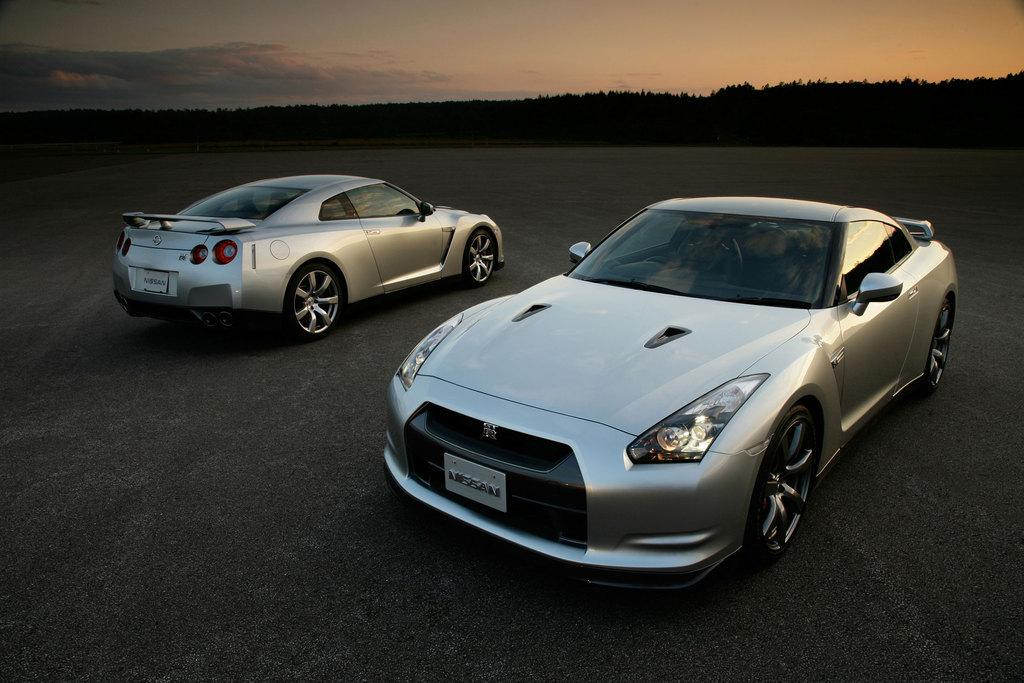How many cars can be seen in the image? There are two cars in the image. Where are the cars located? The cars are placed on the ground. What can be seen in the background of the image? There is a group of trees and the sky visible in the background of the image. What is the condition of the sky in the image? The sky appears to be cloudy in the image. What type of amusement can be seen in the image? There is no amusement present in the image; it features two cars on the ground with a cloudy sky and trees in the background. 